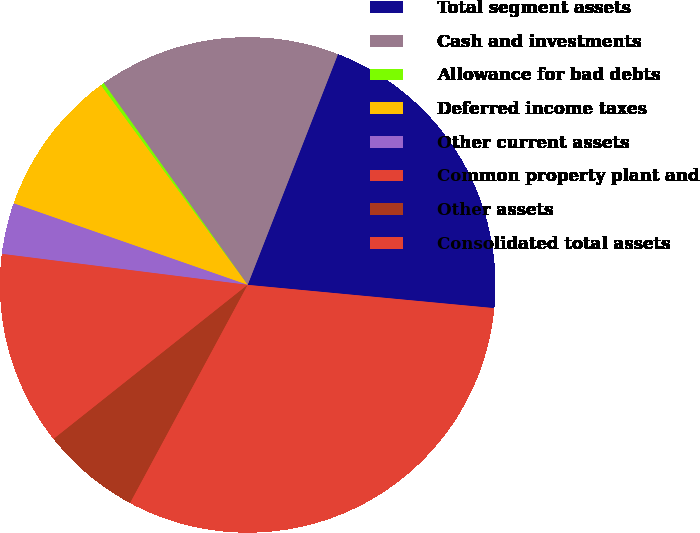Convert chart to OTSL. <chart><loc_0><loc_0><loc_500><loc_500><pie_chart><fcel>Total segment assets<fcel>Cash and investments<fcel>Allowance for bad debts<fcel>Deferred income taxes<fcel>Other current assets<fcel>Common property plant and<fcel>Other assets<fcel>Consolidated total assets<nl><fcel>20.56%<fcel>15.8%<fcel>0.23%<fcel>9.57%<fcel>3.34%<fcel>12.68%<fcel>6.45%<fcel>31.37%<nl></chart> 